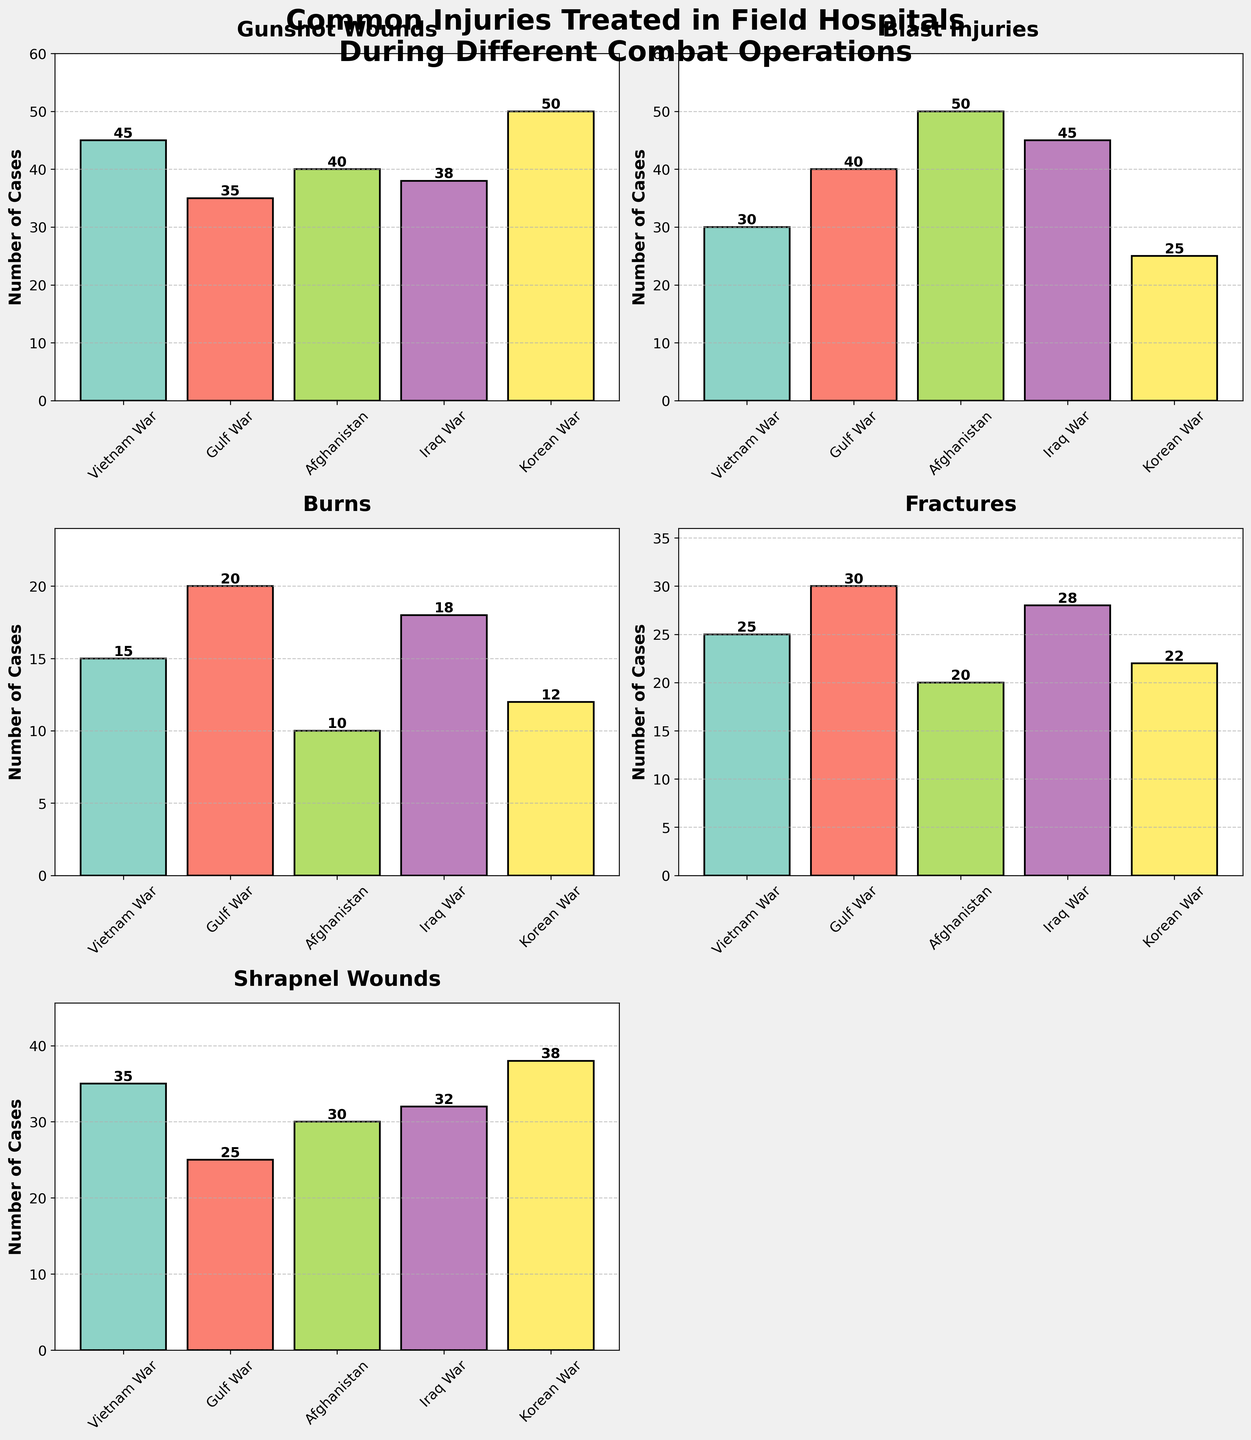What's the title of the figure? The title of the figure is displayed prominently at the top, summarizing the content.
Answer: Common Injuries Treated in Field Hospitals During Different Combat Operations How many combat operations are displayed in each subplot? Each subplot shows data for five different combat operations, as listed along the x-axis: Vietnam War, Gulf War, Afghanistan, Iraq War, and Korean War.
Answer: 5 In which combat operation were the most blast injuries treated? By comparing the heights of the bars labeled "Blast Injuries" across all operations, we see that Afghanistan has the tallest bar.
Answer: Afghanistan Which operation has the highest number of fractures? Checking the bars for "Fractures" across all operations, the Gulf War has the tallest bar, indicating the highest number of fractures.
Answer: Gulf War What's the difference in the number of shrapnel wounds between the Vietnam War and the Gulf War? Find the heights of the bars labeled "Shrapnel Wounds" for both operations and subtract the Gulf War value from the Vietnam War value (35 - 25).
Answer: 10 What's the average number of burn injuries across all operations? Add the values of burn injuries for all combat operations and divide by the number of operations: (15 + 20 + 10 + 18 + 12) / 5.
Answer: 15 Compare the number of gunshot wounds in the Korean War and the Vietnam War. Which is higher? The bars for "Gunshot Wounds" indicate 50 for the Korean War and 45 for the Vietnam War. The Korean War has a higher number.
Answer: Korean War Which combat operation treated the least number of burns? By observing the heights of the bars labeled "Burns" in all operations, Afghanistan has the shortest bar.
Answer: Afghanistan What's the total number of injuries treated in the Iraq War across all types shown? Sum the injuries for the Iraq War across all categories: 38 + 45 + 18 + 28 + 32.
Answer: 161 Which combat operation has the smallest range in the number of injuries across different categories? Find the range (difference between the highest and lowest number of injuries) for each operation and compare. Gulf War has injuries ranging from 20 to 40 (range = 20), which is the smallest.
Answer: Gulf War 